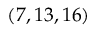Convert formula to latex. <formula><loc_0><loc_0><loc_500><loc_500>( 7 , 1 3 , 1 6 )</formula> 